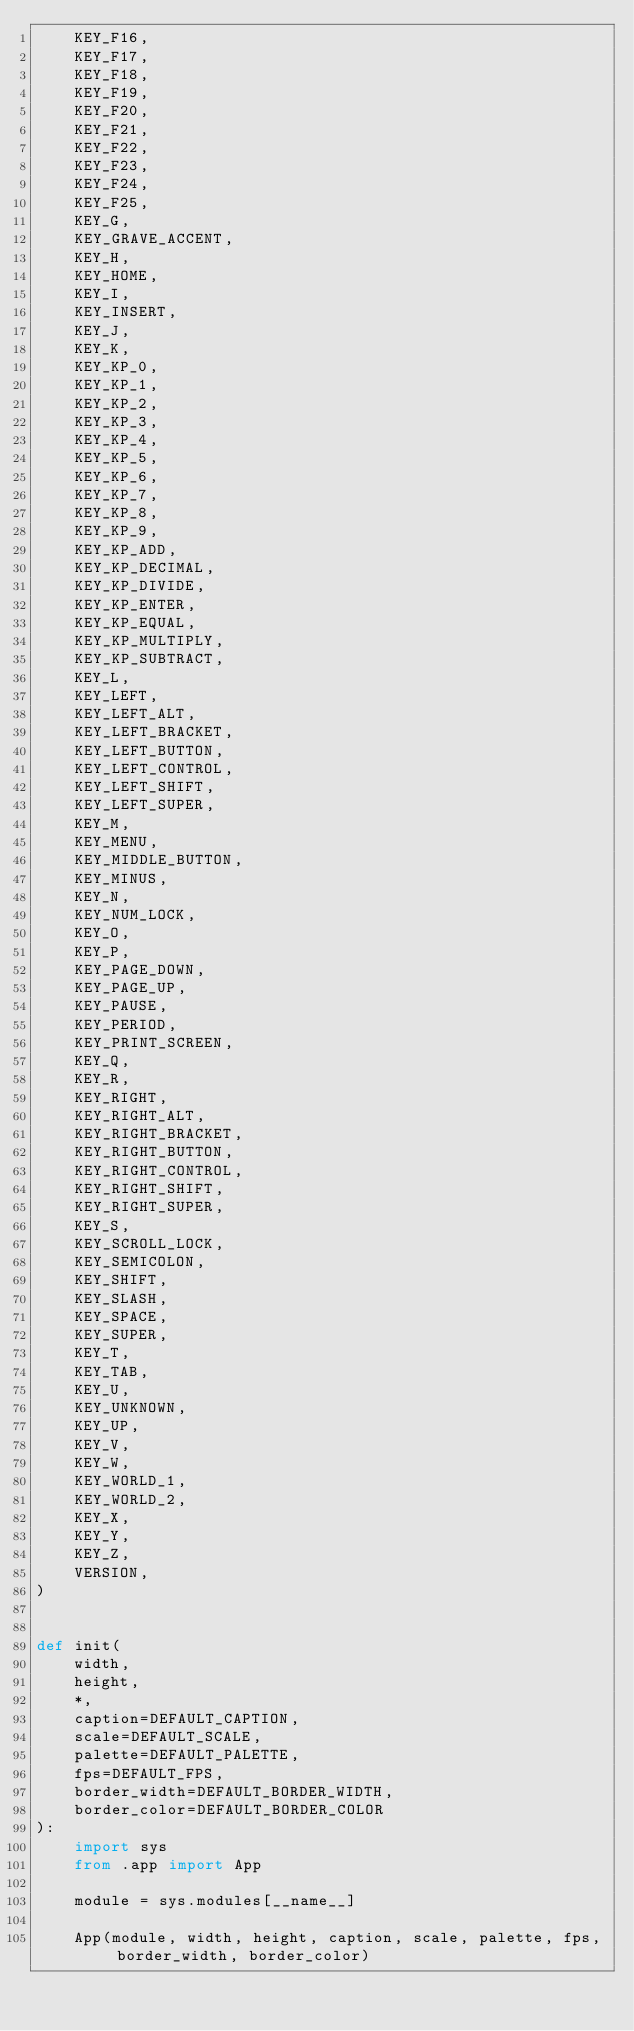<code> <loc_0><loc_0><loc_500><loc_500><_Python_>    KEY_F16,
    KEY_F17,
    KEY_F18,
    KEY_F19,
    KEY_F20,
    KEY_F21,
    KEY_F22,
    KEY_F23,
    KEY_F24,
    KEY_F25,
    KEY_G,
    KEY_GRAVE_ACCENT,
    KEY_H,
    KEY_HOME,
    KEY_I,
    KEY_INSERT,
    KEY_J,
    KEY_K,
    KEY_KP_0,
    KEY_KP_1,
    KEY_KP_2,
    KEY_KP_3,
    KEY_KP_4,
    KEY_KP_5,
    KEY_KP_6,
    KEY_KP_7,
    KEY_KP_8,
    KEY_KP_9,
    KEY_KP_ADD,
    KEY_KP_DECIMAL,
    KEY_KP_DIVIDE,
    KEY_KP_ENTER,
    KEY_KP_EQUAL,
    KEY_KP_MULTIPLY,
    KEY_KP_SUBTRACT,
    KEY_L,
    KEY_LEFT,
    KEY_LEFT_ALT,
    KEY_LEFT_BRACKET,
    KEY_LEFT_BUTTON,
    KEY_LEFT_CONTROL,
    KEY_LEFT_SHIFT,
    KEY_LEFT_SUPER,
    KEY_M,
    KEY_MENU,
    KEY_MIDDLE_BUTTON,
    KEY_MINUS,
    KEY_N,
    KEY_NUM_LOCK,
    KEY_O,
    KEY_P,
    KEY_PAGE_DOWN,
    KEY_PAGE_UP,
    KEY_PAUSE,
    KEY_PERIOD,
    KEY_PRINT_SCREEN,
    KEY_Q,
    KEY_R,
    KEY_RIGHT,
    KEY_RIGHT_ALT,
    KEY_RIGHT_BRACKET,
    KEY_RIGHT_BUTTON,
    KEY_RIGHT_CONTROL,
    KEY_RIGHT_SHIFT,
    KEY_RIGHT_SUPER,
    KEY_S,
    KEY_SCROLL_LOCK,
    KEY_SEMICOLON,
    KEY_SHIFT,
    KEY_SLASH,
    KEY_SPACE,
    KEY_SUPER,
    KEY_T,
    KEY_TAB,
    KEY_U,
    KEY_UNKNOWN,
    KEY_UP,
    KEY_V,
    KEY_W,
    KEY_WORLD_1,
    KEY_WORLD_2,
    KEY_X,
    KEY_Y,
    KEY_Z,
    VERSION,
)


def init(
    width,
    height,
    *,
    caption=DEFAULT_CAPTION,
    scale=DEFAULT_SCALE,
    palette=DEFAULT_PALETTE,
    fps=DEFAULT_FPS,
    border_width=DEFAULT_BORDER_WIDTH,
    border_color=DEFAULT_BORDER_COLOR
):
    import sys
    from .app import App

    module = sys.modules[__name__]

    App(module, width, height, caption, scale, palette, fps, border_width, border_color)
</code> 